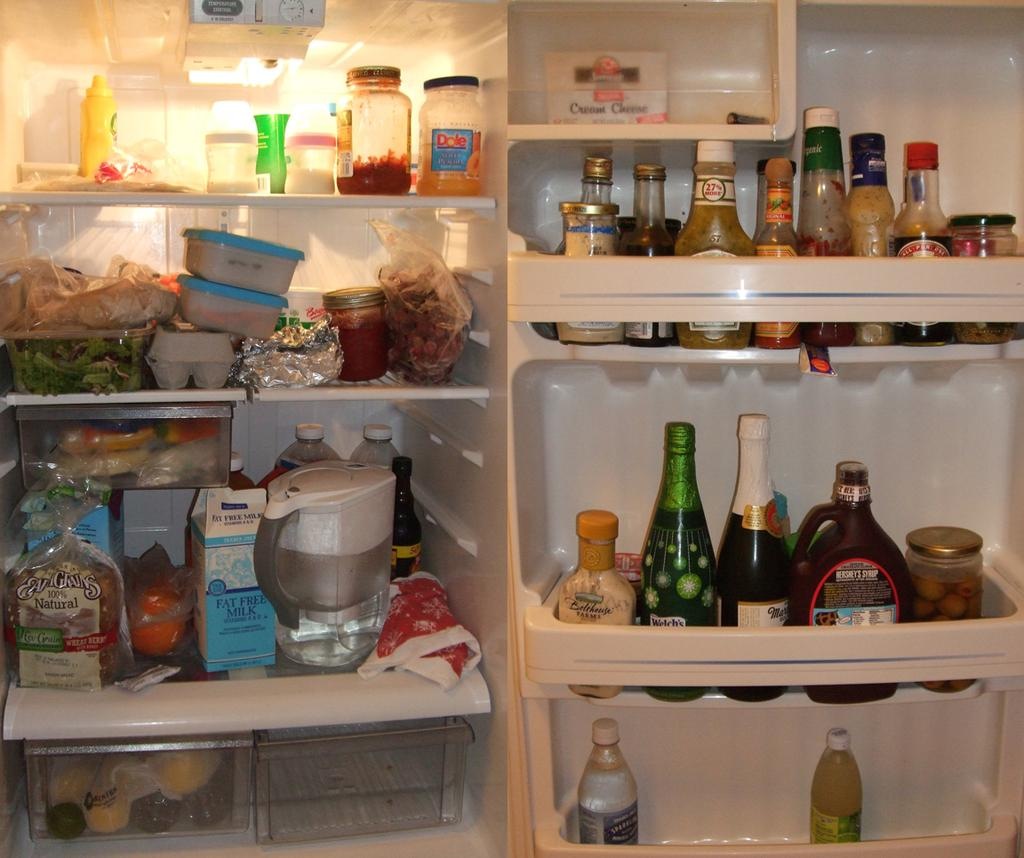<image>
Create a compact narrative representing the image presented. an open fridge with things like FAT FREE Milk and 100% natural bread inside 